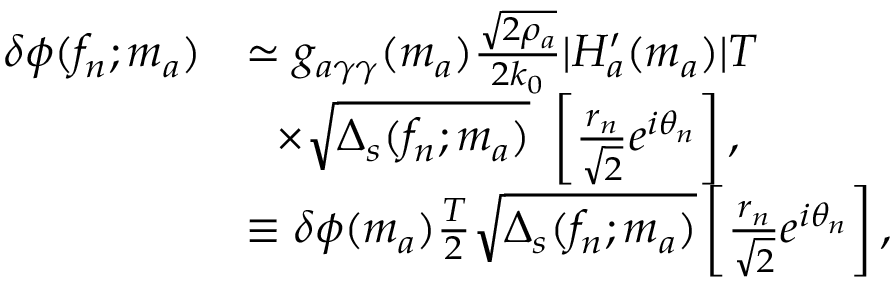<formula> <loc_0><loc_0><loc_500><loc_500>\begin{array} { r l } { \delta \phi ( f _ { n } ; m _ { a } ) } & { \simeq g _ { a \gamma \gamma } ( m _ { a } ) \frac { \sqrt { 2 \rho _ { a } } } { 2 k _ { 0 } } | H _ { a } ^ { \prime } ( m _ { a } ) | T } \\ & { \times \sqrt { \Delta _ { s } ( f _ { n } ; m _ { a } ) } \left [ \frac { r _ { n } } { { \sqrt { 2 } } } e ^ { i \theta _ { n } } \right ] , } \\ & { \equiv \delta \phi ( m _ { a } ) \frac { T } { 2 } \sqrt { \Delta _ { s } ( f _ { n } ; m _ { a } ) } \left [ \frac { r _ { n } } { { \sqrt { 2 } } } e ^ { i \theta _ { n } } \right ] , } \end{array}</formula> 